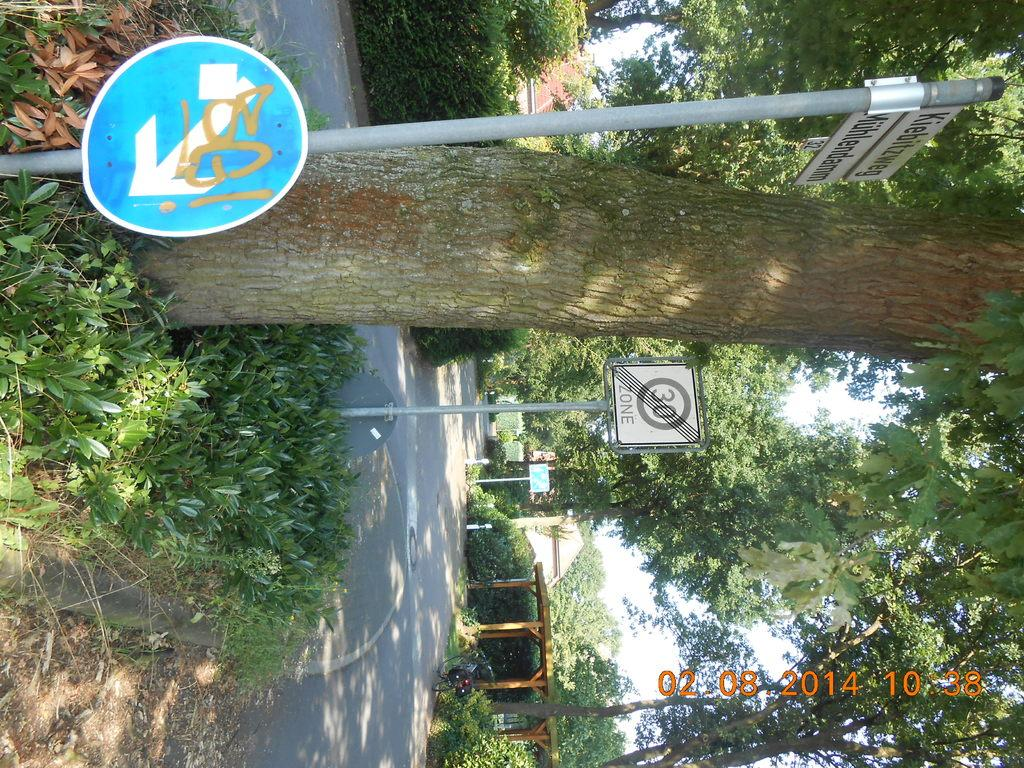<image>
Provide a brief description of the given image. a sign that has the number 30 on it 